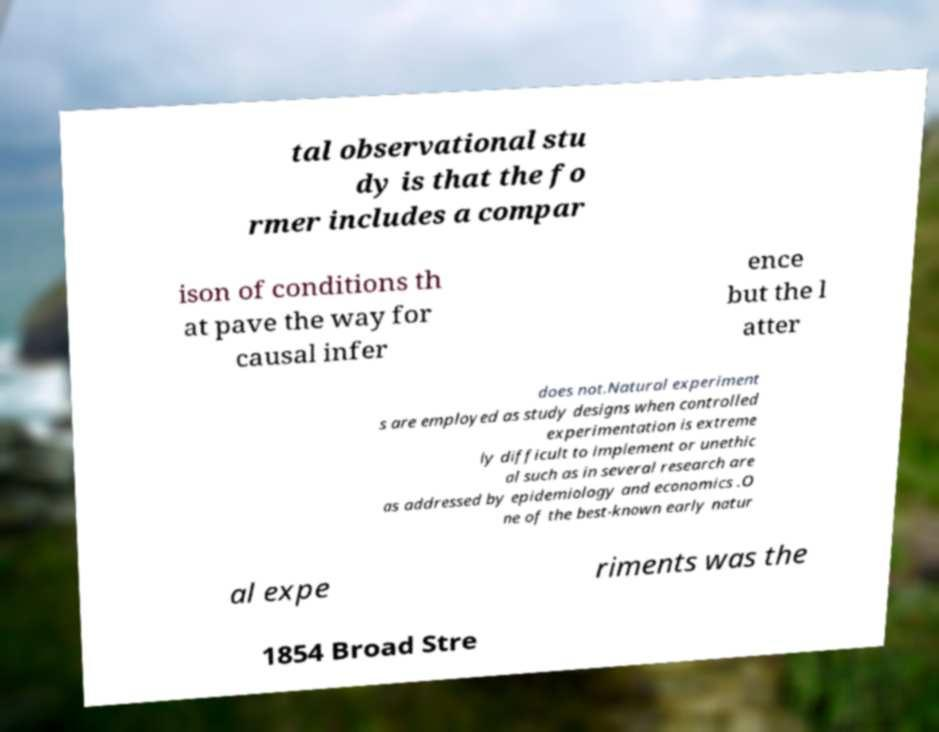Could you assist in decoding the text presented in this image and type it out clearly? tal observational stu dy is that the fo rmer includes a compar ison of conditions th at pave the way for causal infer ence but the l atter does not.Natural experiment s are employed as study designs when controlled experimentation is extreme ly difficult to implement or unethic al such as in several research are as addressed by epidemiology and economics .O ne of the best-known early natur al expe riments was the 1854 Broad Stre 